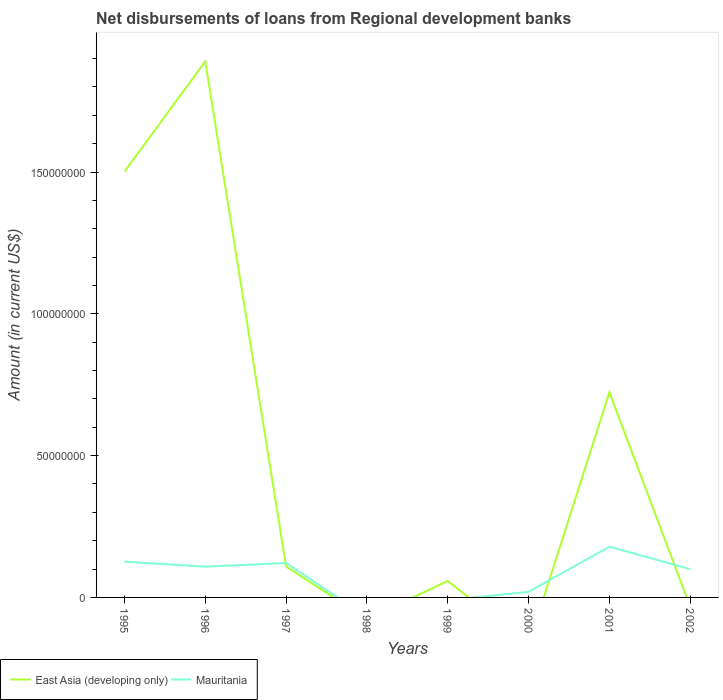How many different coloured lines are there?
Make the answer very short. 2. Is the number of lines equal to the number of legend labels?
Give a very brief answer. No. What is the total amount of disbursements of loans from regional development banks in East Asia (developing only) in the graph?
Your response must be concise. -3.88e+07. What is the difference between the highest and the second highest amount of disbursements of loans from regional development banks in Mauritania?
Provide a succinct answer. 1.79e+07. What is the difference between the highest and the lowest amount of disbursements of loans from regional development banks in East Asia (developing only)?
Your answer should be very brief. 3. How many years are there in the graph?
Offer a terse response. 8. What is the difference between two consecutive major ticks on the Y-axis?
Keep it short and to the point. 5.00e+07. Are the values on the major ticks of Y-axis written in scientific E-notation?
Keep it short and to the point. No. Does the graph contain grids?
Your answer should be very brief. No. How many legend labels are there?
Provide a short and direct response. 2. How are the legend labels stacked?
Make the answer very short. Horizontal. What is the title of the graph?
Give a very brief answer. Net disbursements of loans from Regional development banks. Does "Turkmenistan" appear as one of the legend labels in the graph?
Provide a short and direct response. No. What is the label or title of the Y-axis?
Ensure brevity in your answer.  Amount (in current US$). What is the Amount (in current US$) in East Asia (developing only) in 1995?
Make the answer very short. 1.50e+08. What is the Amount (in current US$) in Mauritania in 1995?
Provide a succinct answer. 1.26e+07. What is the Amount (in current US$) of East Asia (developing only) in 1996?
Your answer should be compact. 1.89e+08. What is the Amount (in current US$) of Mauritania in 1996?
Give a very brief answer. 1.08e+07. What is the Amount (in current US$) of East Asia (developing only) in 1997?
Ensure brevity in your answer.  1.09e+07. What is the Amount (in current US$) of Mauritania in 1997?
Offer a very short reply. 1.21e+07. What is the Amount (in current US$) in East Asia (developing only) in 1998?
Your answer should be compact. 0. What is the Amount (in current US$) of Mauritania in 1998?
Provide a short and direct response. 0. What is the Amount (in current US$) of East Asia (developing only) in 1999?
Offer a very short reply. 5.81e+06. What is the Amount (in current US$) of Mauritania in 1999?
Make the answer very short. 0. What is the Amount (in current US$) in Mauritania in 2000?
Your answer should be very brief. 1.97e+06. What is the Amount (in current US$) in East Asia (developing only) in 2001?
Provide a succinct answer. 7.23e+07. What is the Amount (in current US$) of Mauritania in 2001?
Keep it short and to the point. 1.79e+07. What is the Amount (in current US$) in East Asia (developing only) in 2002?
Your answer should be very brief. 0. What is the Amount (in current US$) in Mauritania in 2002?
Your response must be concise. 9.98e+06. Across all years, what is the maximum Amount (in current US$) of East Asia (developing only)?
Give a very brief answer. 1.89e+08. Across all years, what is the maximum Amount (in current US$) of Mauritania?
Your answer should be compact. 1.79e+07. Across all years, what is the minimum Amount (in current US$) in East Asia (developing only)?
Give a very brief answer. 0. Across all years, what is the minimum Amount (in current US$) of Mauritania?
Provide a succinct answer. 0. What is the total Amount (in current US$) of East Asia (developing only) in the graph?
Keep it short and to the point. 4.28e+08. What is the total Amount (in current US$) of Mauritania in the graph?
Your answer should be compact. 6.54e+07. What is the difference between the Amount (in current US$) in East Asia (developing only) in 1995 and that in 1996?
Provide a short and direct response. -3.88e+07. What is the difference between the Amount (in current US$) of Mauritania in 1995 and that in 1996?
Provide a succinct answer. 1.77e+06. What is the difference between the Amount (in current US$) of East Asia (developing only) in 1995 and that in 1997?
Offer a terse response. 1.39e+08. What is the difference between the Amount (in current US$) in Mauritania in 1995 and that in 1997?
Give a very brief answer. 4.74e+05. What is the difference between the Amount (in current US$) in East Asia (developing only) in 1995 and that in 1999?
Give a very brief answer. 1.44e+08. What is the difference between the Amount (in current US$) of Mauritania in 1995 and that in 2000?
Give a very brief answer. 1.07e+07. What is the difference between the Amount (in current US$) in East Asia (developing only) in 1995 and that in 2001?
Give a very brief answer. 7.78e+07. What is the difference between the Amount (in current US$) of Mauritania in 1995 and that in 2001?
Your response must be concise. -5.26e+06. What is the difference between the Amount (in current US$) in Mauritania in 1995 and that in 2002?
Keep it short and to the point. 2.64e+06. What is the difference between the Amount (in current US$) of East Asia (developing only) in 1996 and that in 1997?
Your answer should be very brief. 1.78e+08. What is the difference between the Amount (in current US$) in Mauritania in 1996 and that in 1997?
Provide a short and direct response. -1.30e+06. What is the difference between the Amount (in current US$) of East Asia (developing only) in 1996 and that in 1999?
Your answer should be compact. 1.83e+08. What is the difference between the Amount (in current US$) of Mauritania in 1996 and that in 2000?
Offer a terse response. 8.88e+06. What is the difference between the Amount (in current US$) in East Asia (developing only) in 1996 and that in 2001?
Your response must be concise. 1.17e+08. What is the difference between the Amount (in current US$) in Mauritania in 1996 and that in 2001?
Provide a short and direct response. -7.03e+06. What is the difference between the Amount (in current US$) in Mauritania in 1996 and that in 2002?
Offer a very short reply. 8.64e+05. What is the difference between the Amount (in current US$) in East Asia (developing only) in 1997 and that in 1999?
Give a very brief answer. 5.08e+06. What is the difference between the Amount (in current US$) in Mauritania in 1997 and that in 2000?
Your answer should be compact. 1.02e+07. What is the difference between the Amount (in current US$) in East Asia (developing only) in 1997 and that in 2001?
Make the answer very short. -6.14e+07. What is the difference between the Amount (in current US$) of Mauritania in 1997 and that in 2001?
Provide a short and direct response. -5.73e+06. What is the difference between the Amount (in current US$) in Mauritania in 1997 and that in 2002?
Give a very brief answer. 2.16e+06. What is the difference between the Amount (in current US$) in East Asia (developing only) in 1999 and that in 2001?
Provide a succinct answer. -6.65e+07. What is the difference between the Amount (in current US$) of Mauritania in 2000 and that in 2001?
Offer a very short reply. -1.59e+07. What is the difference between the Amount (in current US$) of Mauritania in 2000 and that in 2002?
Provide a short and direct response. -8.01e+06. What is the difference between the Amount (in current US$) in Mauritania in 2001 and that in 2002?
Provide a short and direct response. 7.90e+06. What is the difference between the Amount (in current US$) of East Asia (developing only) in 1995 and the Amount (in current US$) of Mauritania in 1996?
Give a very brief answer. 1.39e+08. What is the difference between the Amount (in current US$) of East Asia (developing only) in 1995 and the Amount (in current US$) of Mauritania in 1997?
Make the answer very short. 1.38e+08. What is the difference between the Amount (in current US$) of East Asia (developing only) in 1995 and the Amount (in current US$) of Mauritania in 2000?
Offer a terse response. 1.48e+08. What is the difference between the Amount (in current US$) in East Asia (developing only) in 1995 and the Amount (in current US$) in Mauritania in 2001?
Offer a very short reply. 1.32e+08. What is the difference between the Amount (in current US$) of East Asia (developing only) in 1995 and the Amount (in current US$) of Mauritania in 2002?
Offer a very short reply. 1.40e+08. What is the difference between the Amount (in current US$) in East Asia (developing only) in 1996 and the Amount (in current US$) in Mauritania in 1997?
Your answer should be very brief. 1.77e+08. What is the difference between the Amount (in current US$) in East Asia (developing only) in 1996 and the Amount (in current US$) in Mauritania in 2000?
Your response must be concise. 1.87e+08. What is the difference between the Amount (in current US$) of East Asia (developing only) in 1996 and the Amount (in current US$) of Mauritania in 2001?
Your answer should be very brief. 1.71e+08. What is the difference between the Amount (in current US$) in East Asia (developing only) in 1996 and the Amount (in current US$) in Mauritania in 2002?
Make the answer very short. 1.79e+08. What is the difference between the Amount (in current US$) of East Asia (developing only) in 1997 and the Amount (in current US$) of Mauritania in 2000?
Offer a terse response. 8.92e+06. What is the difference between the Amount (in current US$) of East Asia (developing only) in 1997 and the Amount (in current US$) of Mauritania in 2001?
Make the answer very short. -6.99e+06. What is the difference between the Amount (in current US$) of East Asia (developing only) in 1997 and the Amount (in current US$) of Mauritania in 2002?
Give a very brief answer. 9.10e+05. What is the difference between the Amount (in current US$) of East Asia (developing only) in 1999 and the Amount (in current US$) of Mauritania in 2000?
Offer a very short reply. 3.84e+06. What is the difference between the Amount (in current US$) of East Asia (developing only) in 1999 and the Amount (in current US$) of Mauritania in 2001?
Offer a very short reply. -1.21e+07. What is the difference between the Amount (in current US$) in East Asia (developing only) in 1999 and the Amount (in current US$) in Mauritania in 2002?
Your answer should be compact. -4.17e+06. What is the difference between the Amount (in current US$) in East Asia (developing only) in 2001 and the Amount (in current US$) in Mauritania in 2002?
Keep it short and to the point. 6.23e+07. What is the average Amount (in current US$) of East Asia (developing only) per year?
Offer a terse response. 5.35e+07. What is the average Amount (in current US$) of Mauritania per year?
Your response must be concise. 8.18e+06. In the year 1995, what is the difference between the Amount (in current US$) of East Asia (developing only) and Amount (in current US$) of Mauritania?
Provide a succinct answer. 1.38e+08. In the year 1996, what is the difference between the Amount (in current US$) in East Asia (developing only) and Amount (in current US$) in Mauritania?
Make the answer very short. 1.78e+08. In the year 1997, what is the difference between the Amount (in current US$) in East Asia (developing only) and Amount (in current US$) in Mauritania?
Your answer should be compact. -1.25e+06. In the year 2001, what is the difference between the Amount (in current US$) in East Asia (developing only) and Amount (in current US$) in Mauritania?
Provide a succinct answer. 5.44e+07. What is the ratio of the Amount (in current US$) in East Asia (developing only) in 1995 to that in 1996?
Give a very brief answer. 0.79. What is the ratio of the Amount (in current US$) of Mauritania in 1995 to that in 1996?
Make the answer very short. 1.16. What is the ratio of the Amount (in current US$) in East Asia (developing only) in 1995 to that in 1997?
Your response must be concise. 13.79. What is the ratio of the Amount (in current US$) in Mauritania in 1995 to that in 1997?
Your answer should be very brief. 1.04. What is the ratio of the Amount (in current US$) of East Asia (developing only) in 1995 to that in 1999?
Provide a short and direct response. 25.85. What is the ratio of the Amount (in current US$) of Mauritania in 1995 to that in 2000?
Your answer should be very brief. 6.41. What is the ratio of the Amount (in current US$) of East Asia (developing only) in 1995 to that in 2001?
Your answer should be very brief. 2.08. What is the ratio of the Amount (in current US$) in Mauritania in 1995 to that in 2001?
Make the answer very short. 0.71. What is the ratio of the Amount (in current US$) in Mauritania in 1995 to that in 2002?
Ensure brevity in your answer.  1.26. What is the ratio of the Amount (in current US$) in East Asia (developing only) in 1996 to that in 1997?
Offer a very short reply. 17.35. What is the ratio of the Amount (in current US$) in Mauritania in 1996 to that in 1997?
Your answer should be compact. 0.89. What is the ratio of the Amount (in current US$) of East Asia (developing only) in 1996 to that in 1999?
Keep it short and to the point. 32.53. What is the ratio of the Amount (in current US$) of Mauritania in 1996 to that in 2000?
Your response must be concise. 5.51. What is the ratio of the Amount (in current US$) in East Asia (developing only) in 1996 to that in 2001?
Make the answer very short. 2.61. What is the ratio of the Amount (in current US$) in Mauritania in 1996 to that in 2001?
Provide a short and direct response. 0.61. What is the ratio of the Amount (in current US$) in Mauritania in 1996 to that in 2002?
Keep it short and to the point. 1.09. What is the ratio of the Amount (in current US$) in East Asia (developing only) in 1997 to that in 1999?
Provide a short and direct response. 1.87. What is the ratio of the Amount (in current US$) of Mauritania in 1997 to that in 2000?
Your answer should be compact. 6.17. What is the ratio of the Amount (in current US$) of East Asia (developing only) in 1997 to that in 2001?
Give a very brief answer. 0.15. What is the ratio of the Amount (in current US$) of Mauritania in 1997 to that in 2001?
Your response must be concise. 0.68. What is the ratio of the Amount (in current US$) in Mauritania in 1997 to that in 2002?
Offer a terse response. 1.22. What is the ratio of the Amount (in current US$) of East Asia (developing only) in 1999 to that in 2001?
Your answer should be very brief. 0.08. What is the ratio of the Amount (in current US$) in Mauritania in 2000 to that in 2001?
Ensure brevity in your answer.  0.11. What is the ratio of the Amount (in current US$) in Mauritania in 2000 to that in 2002?
Offer a terse response. 0.2. What is the ratio of the Amount (in current US$) of Mauritania in 2001 to that in 2002?
Your answer should be compact. 1.79. What is the difference between the highest and the second highest Amount (in current US$) in East Asia (developing only)?
Ensure brevity in your answer.  3.88e+07. What is the difference between the highest and the second highest Amount (in current US$) in Mauritania?
Your answer should be very brief. 5.26e+06. What is the difference between the highest and the lowest Amount (in current US$) of East Asia (developing only)?
Keep it short and to the point. 1.89e+08. What is the difference between the highest and the lowest Amount (in current US$) in Mauritania?
Give a very brief answer. 1.79e+07. 